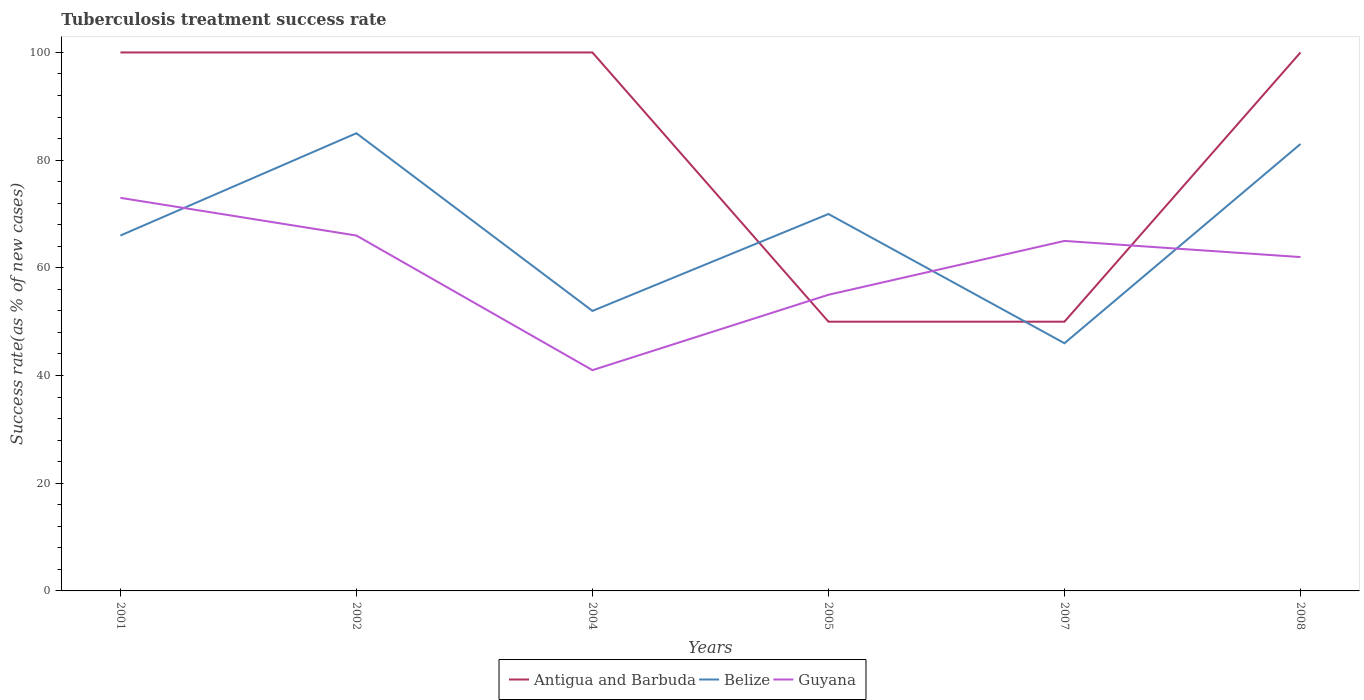How many different coloured lines are there?
Offer a very short reply. 3. Is the number of lines equal to the number of legend labels?
Give a very brief answer. Yes. Across all years, what is the maximum tuberculosis treatment success rate in Belize?
Offer a terse response. 46. In which year was the tuberculosis treatment success rate in Guyana maximum?
Your answer should be compact. 2004. How many lines are there?
Keep it short and to the point. 3. What is the difference between two consecutive major ticks on the Y-axis?
Provide a succinct answer. 20. Are the values on the major ticks of Y-axis written in scientific E-notation?
Offer a terse response. No. Does the graph contain any zero values?
Offer a terse response. No. Does the graph contain grids?
Keep it short and to the point. No. How are the legend labels stacked?
Make the answer very short. Horizontal. What is the title of the graph?
Provide a short and direct response. Tuberculosis treatment success rate. Does "Poland" appear as one of the legend labels in the graph?
Ensure brevity in your answer.  No. What is the label or title of the X-axis?
Offer a very short reply. Years. What is the label or title of the Y-axis?
Offer a very short reply. Success rate(as % of new cases). What is the Success rate(as % of new cases) in Antigua and Barbuda in 2002?
Your answer should be very brief. 100. What is the Success rate(as % of new cases) in Guyana in 2002?
Keep it short and to the point. 66. What is the Success rate(as % of new cases) of Antigua and Barbuda in 2004?
Provide a succinct answer. 100. What is the Success rate(as % of new cases) in Belize in 2004?
Make the answer very short. 52. What is the Success rate(as % of new cases) in Belize in 2005?
Give a very brief answer. 70. What is the Success rate(as % of new cases) in Belize in 2007?
Your answer should be very brief. 46. What is the Success rate(as % of new cases) in Guyana in 2007?
Your answer should be compact. 65. What is the Success rate(as % of new cases) in Belize in 2008?
Your response must be concise. 83. Across all years, what is the maximum Success rate(as % of new cases) in Antigua and Barbuda?
Keep it short and to the point. 100. Across all years, what is the maximum Success rate(as % of new cases) of Belize?
Make the answer very short. 85. Across all years, what is the minimum Success rate(as % of new cases) of Antigua and Barbuda?
Your answer should be compact. 50. What is the total Success rate(as % of new cases) in Antigua and Barbuda in the graph?
Your response must be concise. 500. What is the total Success rate(as % of new cases) in Belize in the graph?
Ensure brevity in your answer.  402. What is the total Success rate(as % of new cases) in Guyana in the graph?
Your answer should be compact. 362. What is the difference between the Success rate(as % of new cases) in Guyana in 2001 and that in 2002?
Offer a terse response. 7. What is the difference between the Success rate(as % of new cases) of Antigua and Barbuda in 2001 and that in 2004?
Offer a terse response. 0. What is the difference between the Success rate(as % of new cases) of Guyana in 2001 and that in 2004?
Ensure brevity in your answer.  32. What is the difference between the Success rate(as % of new cases) of Guyana in 2001 and that in 2005?
Provide a short and direct response. 18. What is the difference between the Success rate(as % of new cases) in Antigua and Barbuda in 2001 and that in 2007?
Offer a terse response. 50. What is the difference between the Success rate(as % of new cases) in Antigua and Barbuda in 2001 and that in 2008?
Provide a short and direct response. 0. What is the difference between the Success rate(as % of new cases) of Belize in 2001 and that in 2008?
Your response must be concise. -17. What is the difference between the Success rate(as % of new cases) of Antigua and Barbuda in 2002 and that in 2004?
Make the answer very short. 0. What is the difference between the Success rate(as % of new cases) in Belize in 2002 and that in 2005?
Your answer should be compact. 15. What is the difference between the Success rate(as % of new cases) in Antigua and Barbuda in 2002 and that in 2007?
Your answer should be very brief. 50. What is the difference between the Success rate(as % of new cases) in Belize in 2002 and that in 2007?
Your response must be concise. 39. What is the difference between the Success rate(as % of new cases) of Guyana in 2002 and that in 2007?
Provide a short and direct response. 1. What is the difference between the Success rate(as % of new cases) of Antigua and Barbuda in 2002 and that in 2008?
Your response must be concise. 0. What is the difference between the Success rate(as % of new cases) of Guyana in 2002 and that in 2008?
Your answer should be very brief. 4. What is the difference between the Success rate(as % of new cases) in Antigua and Barbuda in 2004 and that in 2005?
Keep it short and to the point. 50. What is the difference between the Success rate(as % of new cases) of Antigua and Barbuda in 2004 and that in 2007?
Your response must be concise. 50. What is the difference between the Success rate(as % of new cases) in Belize in 2004 and that in 2007?
Your answer should be compact. 6. What is the difference between the Success rate(as % of new cases) in Guyana in 2004 and that in 2007?
Keep it short and to the point. -24. What is the difference between the Success rate(as % of new cases) of Antigua and Barbuda in 2004 and that in 2008?
Offer a very short reply. 0. What is the difference between the Success rate(as % of new cases) of Belize in 2004 and that in 2008?
Your answer should be compact. -31. What is the difference between the Success rate(as % of new cases) of Guyana in 2004 and that in 2008?
Your answer should be compact. -21. What is the difference between the Success rate(as % of new cases) in Antigua and Barbuda in 2005 and that in 2007?
Offer a terse response. 0. What is the difference between the Success rate(as % of new cases) in Guyana in 2005 and that in 2007?
Offer a terse response. -10. What is the difference between the Success rate(as % of new cases) of Belize in 2005 and that in 2008?
Your answer should be very brief. -13. What is the difference between the Success rate(as % of new cases) of Guyana in 2005 and that in 2008?
Offer a very short reply. -7. What is the difference between the Success rate(as % of new cases) of Belize in 2007 and that in 2008?
Your answer should be compact. -37. What is the difference between the Success rate(as % of new cases) in Antigua and Barbuda in 2001 and the Success rate(as % of new cases) in Guyana in 2002?
Provide a succinct answer. 34. What is the difference between the Success rate(as % of new cases) in Antigua and Barbuda in 2001 and the Success rate(as % of new cases) in Belize in 2004?
Offer a very short reply. 48. What is the difference between the Success rate(as % of new cases) of Antigua and Barbuda in 2001 and the Success rate(as % of new cases) of Guyana in 2004?
Ensure brevity in your answer.  59. What is the difference between the Success rate(as % of new cases) of Belize in 2001 and the Success rate(as % of new cases) of Guyana in 2005?
Provide a succinct answer. 11. What is the difference between the Success rate(as % of new cases) in Antigua and Barbuda in 2001 and the Success rate(as % of new cases) in Belize in 2007?
Offer a very short reply. 54. What is the difference between the Success rate(as % of new cases) in Antigua and Barbuda in 2001 and the Success rate(as % of new cases) in Guyana in 2008?
Provide a short and direct response. 38. What is the difference between the Success rate(as % of new cases) in Belize in 2001 and the Success rate(as % of new cases) in Guyana in 2008?
Offer a very short reply. 4. What is the difference between the Success rate(as % of new cases) of Antigua and Barbuda in 2002 and the Success rate(as % of new cases) of Belize in 2004?
Provide a succinct answer. 48. What is the difference between the Success rate(as % of new cases) in Antigua and Barbuda in 2002 and the Success rate(as % of new cases) in Guyana in 2004?
Offer a very short reply. 59. What is the difference between the Success rate(as % of new cases) in Belize in 2002 and the Success rate(as % of new cases) in Guyana in 2004?
Offer a terse response. 44. What is the difference between the Success rate(as % of new cases) in Antigua and Barbuda in 2002 and the Success rate(as % of new cases) in Belize in 2005?
Give a very brief answer. 30. What is the difference between the Success rate(as % of new cases) of Belize in 2002 and the Success rate(as % of new cases) of Guyana in 2007?
Make the answer very short. 20. What is the difference between the Success rate(as % of new cases) in Antigua and Barbuda in 2002 and the Success rate(as % of new cases) in Belize in 2008?
Your response must be concise. 17. What is the difference between the Success rate(as % of new cases) of Antigua and Barbuda in 2002 and the Success rate(as % of new cases) of Guyana in 2008?
Provide a short and direct response. 38. What is the difference between the Success rate(as % of new cases) in Belize in 2002 and the Success rate(as % of new cases) in Guyana in 2008?
Ensure brevity in your answer.  23. What is the difference between the Success rate(as % of new cases) in Antigua and Barbuda in 2004 and the Success rate(as % of new cases) in Belize in 2005?
Offer a very short reply. 30. What is the difference between the Success rate(as % of new cases) in Belize in 2004 and the Success rate(as % of new cases) in Guyana in 2005?
Offer a terse response. -3. What is the difference between the Success rate(as % of new cases) in Antigua and Barbuda in 2004 and the Success rate(as % of new cases) in Belize in 2007?
Make the answer very short. 54. What is the difference between the Success rate(as % of new cases) of Antigua and Barbuda in 2004 and the Success rate(as % of new cases) of Guyana in 2007?
Your answer should be very brief. 35. What is the difference between the Success rate(as % of new cases) in Belize in 2004 and the Success rate(as % of new cases) in Guyana in 2007?
Ensure brevity in your answer.  -13. What is the difference between the Success rate(as % of new cases) in Antigua and Barbuda in 2005 and the Success rate(as % of new cases) in Belize in 2007?
Keep it short and to the point. 4. What is the difference between the Success rate(as % of new cases) of Antigua and Barbuda in 2005 and the Success rate(as % of new cases) of Guyana in 2007?
Your answer should be compact. -15. What is the difference between the Success rate(as % of new cases) in Antigua and Barbuda in 2005 and the Success rate(as % of new cases) in Belize in 2008?
Keep it short and to the point. -33. What is the difference between the Success rate(as % of new cases) of Antigua and Barbuda in 2005 and the Success rate(as % of new cases) of Guyana in 2008?
Your answer should be compact. -12. What is the difference between the Success rate(as % of new cases) of Antigua and Barbuda in 2007 and the Success rate(as % of new cases) of Belize in 2008?
Your response must be concise. -33. What is the average Success rate(as % of new cases) in Antigua and Barbuda per year?
Your answer should be very brief. 83.33. What is the average Success rate(as % of new cases) of Guyana per year?
Provide a succinct answer. 60.33. In the year 2001, what is the difference between the Success rate(as % of new cases) in Antigua and Barbuda and Success rate(as % of new cases) in Guyana?
Provide a succinct answer. 27. In the year 2001, what is the difference between the Success rate(as % of new cases) of Belize and Success rate(as % of new cases) of Guyana?
Make the answer very short. -7. In the year 2002, what is the difference between the Success rate(as % of new cases) of Antigua and Barbuda and Success rate(as % of new cases) of Guyana?
Your response must be concise. 34. In the year 2004, what is the difference between the Success rate(as % of new cases) in Antigua and Barbuda and Success rate(as % of new cases) in Belize?
Give a very brief answer. 48. In the year 2004, what is the difference between the Success rate(as % of new cases) in Antigua and Barbuda and Success rate(as % of new cases) in Guyana?
Your answer should be very brief. 59. In the year 2004, what is the difference between the Success rate(as % of new cases) in Belize and Success rate(as % of new cases) in Guyana?
Keep it short and to the point. 11. In the year 2005, what is the difference between the Success rate(as % of new cases) in Antigua and Barbuda and Success rate(as % of new cases) in Guyana?
Ensure brevity in your answer.  -5. In the year 2007, what is the difference between the Success rate(as % of new cases) of Antigua and Barbuda and Success rate(as % of new cases) of Guyana?
Make the answer very short. -15. In the year 2008, what is the difference between the Success rate(as % of new cases) of Antigua and Barbuda and Success rate(as % of new cases) of Belize?
Give a very brief answer. 17. In the year 2008, what is the difference between the Success rate(as % of new cases) in Antigua and Barbuda and Success rate(as % of new cases) in Guyana?
Your answer should be very brief. 38. In the year 2008, what is the difference between the Success rate(as % of new cases) of Belize and Success rate(as % of new cases) of Guyana?
Offer a very short reply. 21. What is the ratio of the Success rate(as % of new cases) in Belize in 2001 to that in 2002?
Give a very brief answer. 0.78. What is the ratio of the Success rate(as % of new cases) of Guyana in 2001 to that in 2002?
Offer a very short reply. 1.11. What is the ratio of the Success rate(as % of new cases) of Belize in 2001 to that in 2004?
Your answer should be compact. 1.27. What is the ratio of the Success rate(as % of new cases) in Guyana in 2001 to that in 2004?
Offer a very short reply. 1.78. What is the ratio of the Success rate(as % of new cases) in Antigua and Barbuda in 2001 to that in 2005?
Provide a short and direct response. 2. What is the ratio of the Success rate(as % of new cases) in Belize in 2001 to that in 2005?
Your answer should be very brief. 0.94. What is the ratio of the Success rate(as % of new cases) of Guyana in 2001 to that in 2005?
Offer a very short reply. 1.33. What is the ratio of the Success rate(as % of new cases) of Antigua and Barbuda in 2001 to that in 2007?
Your answer should be compact. 2. What is the ratio of the Success rate(as % of new cases) in Belize in 2001 to that in 2007?
Give a very brief answer. 1.43. What is the ratio of the Success rate(as % of new cases) in Guyana in 2001 to that in 2007?
Your answer should be very brief. 1.12. What is the ratio of the Success rate(as % of new cases) of Antigua and Barbuda in 2001 to that in 2008?
Keep it short and to the point. 1. What is the ratio of the Success rate(as % of new cases) of Belize in 2001 to that in 2008?
Offer a terse response. 0.8. What is the ratio of the Success rate(as % of new cases) in Guyana in 2001 to that in 2008?
Ensure brevity in your answer.  1.18. What is the ratio of the Success rate(as % of new cases) of Antigua and Barbuda in 2002 to that in 2004?
Ensure brevity in your answer.  1. What is the ratio of the Success rate(as % of new cases) of Belize in 2002 to that in 2004?
Your answer should be compact. 1.63. What is the ratio of the Success rate(as % of new cases) of Guyana in 2002 to that in 2004?
Offer a very short reply. 1.61. What is the ratio of the Success rate(as % of new cases) of Antigua and Barbuda in 2002 to that in 2005?
Offer a terse response. 2. What is the ratio of the Success rate(as % of new cases) of Belize in 2002 to that in 2005?
Provide a succinct answer. 1.21. What is the ratio of the Success rate(as % of new cases) in Guyana in 2002 to that in 2005?
Your answer should be compact. 1.2. What is the ratio of the Success rate(as % of new cases) of Antigua and Barbuda in 2002 to that in 2007?
Make the answer very short. 2. What is the ratio of the Success rate(as % of new cases) of Belize in 2002 to that in 2007?
Offer a very short reply. 1.85. What is the ratio of the Success rate(as % of new cases) of Guyana in 2002 to that in 2007?
Your response must be concise. 1.02. What is the ratio of the Success rate(as % of new cases) of Antigua and Barbuda in 2002 to that in 2008?
Your answer should be compact. 1. What is the ratio of the Success rate(as % of new cases) in Belize in 2002 to that in 2008?
Offer a very short reply. 1.02. What is the ratio of the Success rate(as % of new cases) of Guyana in 2002 to that in 2008?
Make the answer very short. 1.06. What is the ratio of the Success rate(as % of new cases) of Belize in 2004 to that in 2005?
Provide a succinct answer. 0.74. What is the ratio of the Success rate(as % of new cases) of Guyana in 2004 to that in 2005?
Provide a short and direct response. 0.75. What is the ratio of the Success rate(as % of new cases) in Belize in 2004 to that in 2007?
Ensure brevity in your answer.  1.13. What is the ratio of the Success rate(as % of new cases) in Guyana in 2004 to that in 2007?
Keep it short and to the point. 0.63. What is the ratio of the Success rate(as % of new cases) of Antigua and Barbuda in 2004 to that in 2008?
Provide a short and direct response. 1. What is the ratio of the Success rate(as % of new cases) of Belize in 2004 to that in 2008?
Make the answer very short. 0.63. What is the ratio of the Success rate(as % of new cases) of Guyana in 2004 to that in 2008?
Offer a very short reply. 0.66. What is the ratio of the Success rate(as % of new cases) of Antigua and Barbuda in 2005 to that in 2007?
Keep it short and to the point. 1. What is the ratio of the Success rate(as % of new cases) in Belize in 2005 to that in 2007?
Give a very brief answer. 1.52. What is the ratio of the Success rate(as % of new cases) in Guyana in 2005 to that in 2007?
Your answer should be very brief. 0.85. What is the ratio of the Success rate(as % of new cases) of Belize in 2005 to that in 2008?
Your response must be concise. 0.84. What is the ratio of the Success rate(as % of new cases) of Guyana in 2005 to that in 2008?
Provide a short and direct response. 0.89. What is the ratio of the Success rate(as % of new cases) in Belize in 2007 to that in 2008?
Ensure brevity in your answer.  0.55. What is the ratio of the Success rate(as % of new cases) of Guyana in 2007 to that in 2008?
Provide a succinct answer. 1.05. What is the difference between the highest and the second highest Success rate(as % of new cases) in Antigua and Barbuda?
Provide a succinct answer. 0. What is the difference between the highest and the second highest Success rate(as % of new cases) in Belize?
Your answer should be very brief. 2. What is the difference between the highest and the lowest Success rate(as % of new cases) in Belize?
Your response must be concise. 39. What is the difference between the highest and the lowest Success rate(as % of new cases) of Guyana?
Provide a short and direct response. 32. 